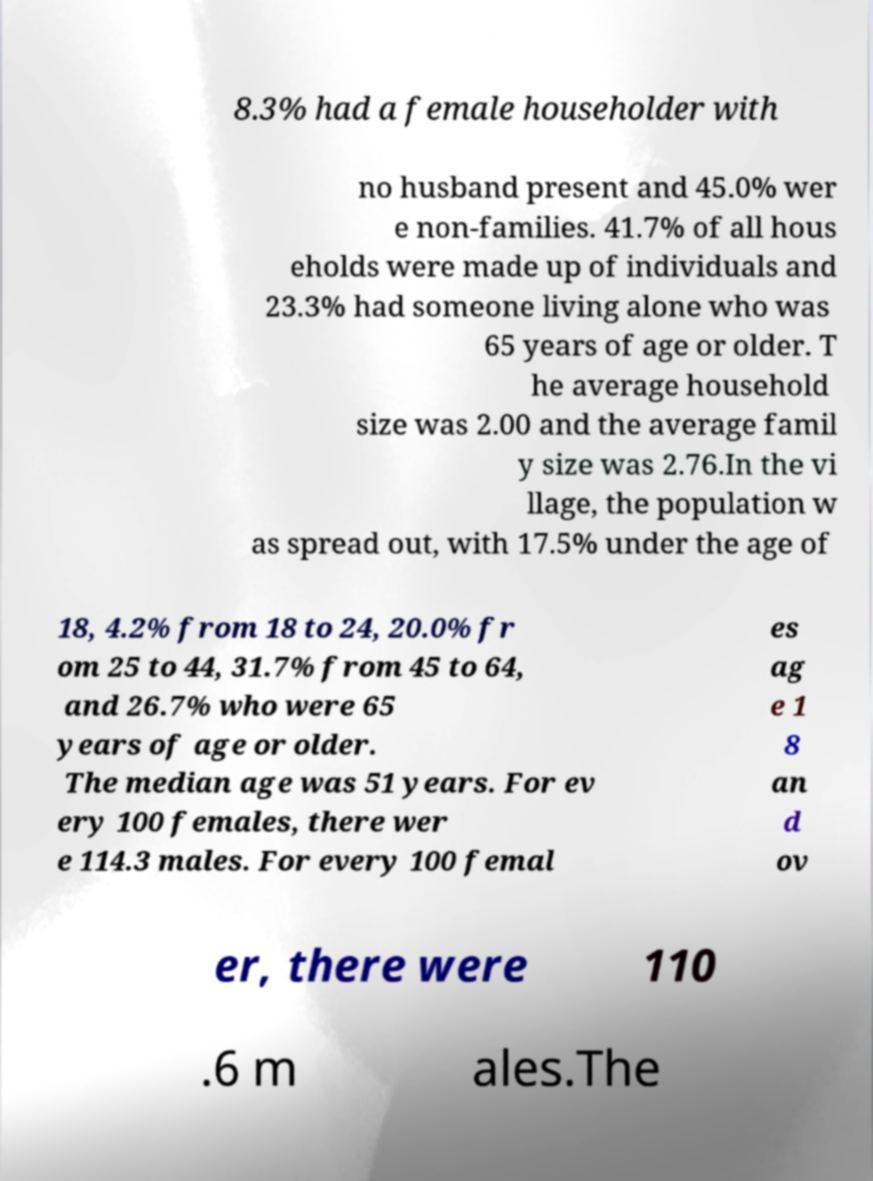I need the written content from this picture converted into text. Can you do that? 8.3% had a female householder with no husband present and 45.0% wer e non-families. 41.7% of all hous eholds were made up of individuals and 23.3% had someone living alone who was 65 years of age or older. T he average household size was 2.00 and the average famil y size was 2.76.In the vi llage, the population w as spread out, with 17.5% under the age of 18, 4.2% from 18 to 24, 20.0% fr om 25 to 44, 31.7% from 45 to 64, and 26.7% who were 65 years of age or older. The median age was 51 years. For ev ery 100 females, there wer e 114.3 males. For every 100 femal es ag e 1 8 an d ov er, there were 110 .6 m ales.The 